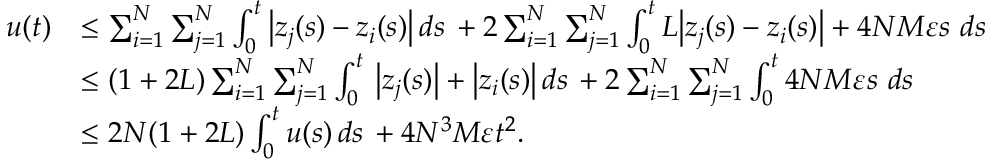<formula> <loc_0><loc_0><loc_500><loc_500>\begin{array} { r l } { u ( t ) } & { \leq \sum _ { i = 1 } ^ { N } \sum _ { j = 1 } ^ { N } \int _ { 0 } ^ { t } \left | z _ { j } ( s ) - z _ { i } ( s ) \right | \, d s \, + 2 \sum _ { i = 1 } ^ { N } \sum _ { j = 1 } ^ { N } \int _ { 0 } ^ { t } L \left | z _ { j } ( s ) - z _ { i } ( s ) \right | + 4 N M \varepsilon s \, d s \, } \\ & { \leq ( 1 + 2 L ) \sum _ { i = 1 } ^ { N } \sum _ { j = 1 } ^ { N } \int _ { 0 } ^ { t } \, \left | z _ { j } ( s ) \right | + \left | z _ { i } ( s ) \right | \, d s \, + 2 \sum _ { i = 1 } ^ { N } \sum _ { j = 1 } ^ { N } \int _ { 0 } ^ { t } 4 N M \varepsilon s \, d s \, } \\ & { \leq 2 N ( 1 + 2 L ) \int _ { 0 } ^ { t } u ( s ) \, d s \, + 4 N ^ { 3 } M \varepsilon t ^ { 2 } . } \end{array}</formula> 